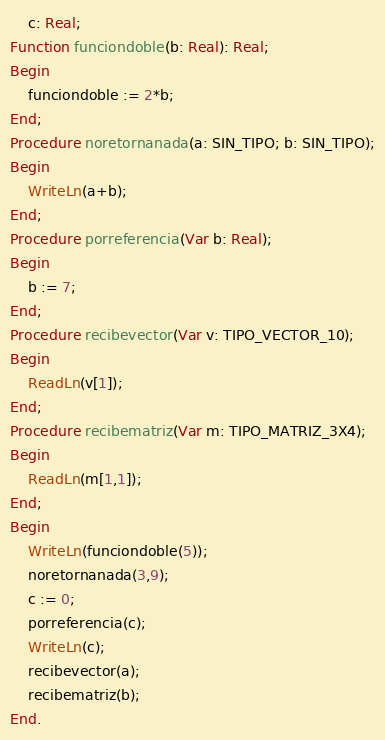<code> <loc_0><loc_0><loc_500><loc_500><_Pascal_>	c: Real;
Function funciondoble(b: Real): Real;
Begin
	funciondoble := 2*b;
End;
Procedure noretornanada(a: SIN_TIPO; b: SIN_TIPO);
Begin
	WriteLn(a+b);
End;
Procedure porreferencia(Var b: Real);
Begin
	b := 7;
End;
Procedure recibevector(Var v: TIPO_VECTOR_10);
Begin
	ReadLn(v[1]);
End;
Procedure recibematriz(Var m: TIPO_MATRIZ_3X4);
Begin
	ReadLn(m[1,1]);
End;
Begin
	WriteLn(funciondoble(5));
	noretornanada(3,9);
	c := 0;
	porreferencia(c);
	WriteLn(c);
	recibevector(a);
	recibematriz(b);
End.
</code> 